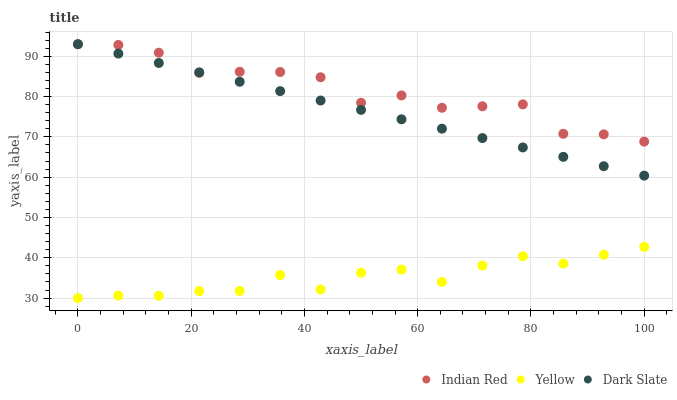Does Yellow have the minimum area under the curve?
Answer yes or no. Yes. Does Indian Red have the maximum area under the curve?
Answer yes or no. Yes. Does Indian Red have the minimum area under the curve?
Answer yes or no. No. Does Yellow have the maximum area under the curve?
Answer yes or no. No. Is Dark Slate the smoothest?
Answer yes or no. Yes. Is Indian Red the roughest?
Answer yes or no. Yes. Is Yellow the smoothest?
Answer yes or no. No. Is Yellow the roughest?
Answer yes or no. No. Does Yellow have the lowest value?
Answer yes or no. Yes. Does Indian Red have the lowest value?
Answer yes or no. No. Does Indian Red have the highest value?
Answer yes or no. Yes. Does Yellow have the highest value?
Answer yes or no. No. Is Yellow less than Dark Slate?
Answer yes or no. Yes. Is Indian Red greater than Yellow?
Answer yes or no. Yes. Does Dark Slate intersect Indian Red?
Answer yes or no. Yes. Is Dark Slate less than Indian Red?
Answer yes or no. No. Is Dark Slate greater than Indian Red?
Answer yes or no. No. Does Yellow intersect Dark Slate?
Answer yes or no. No. 